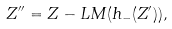Convert formula to latex. <formula><loc_0><loc_0><loc_500><loc_500>Z ^ { \prime \prime } = Z - L M ( h _ { - } ( Z ^ { \prime } ) ) ,</formula> 